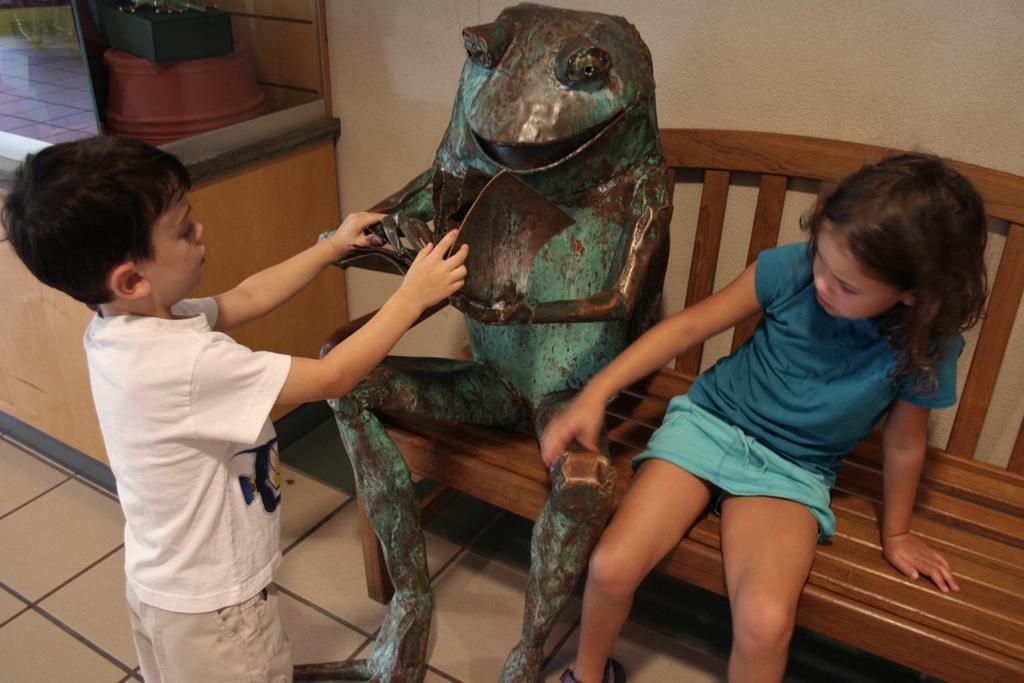Can you describe this image briefly? In this given picture, We can see an iron metal frog which is made kept on a table towards the right, We can see a girl sitting and holding a metal frog towards left bottom, We can see a person standing and holding a metal frog after that, We can see a cream colored wall, a floor. 